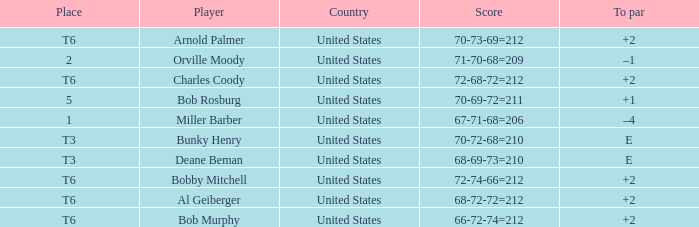What is the score of player bob rosburg? 70-69-72=211. 